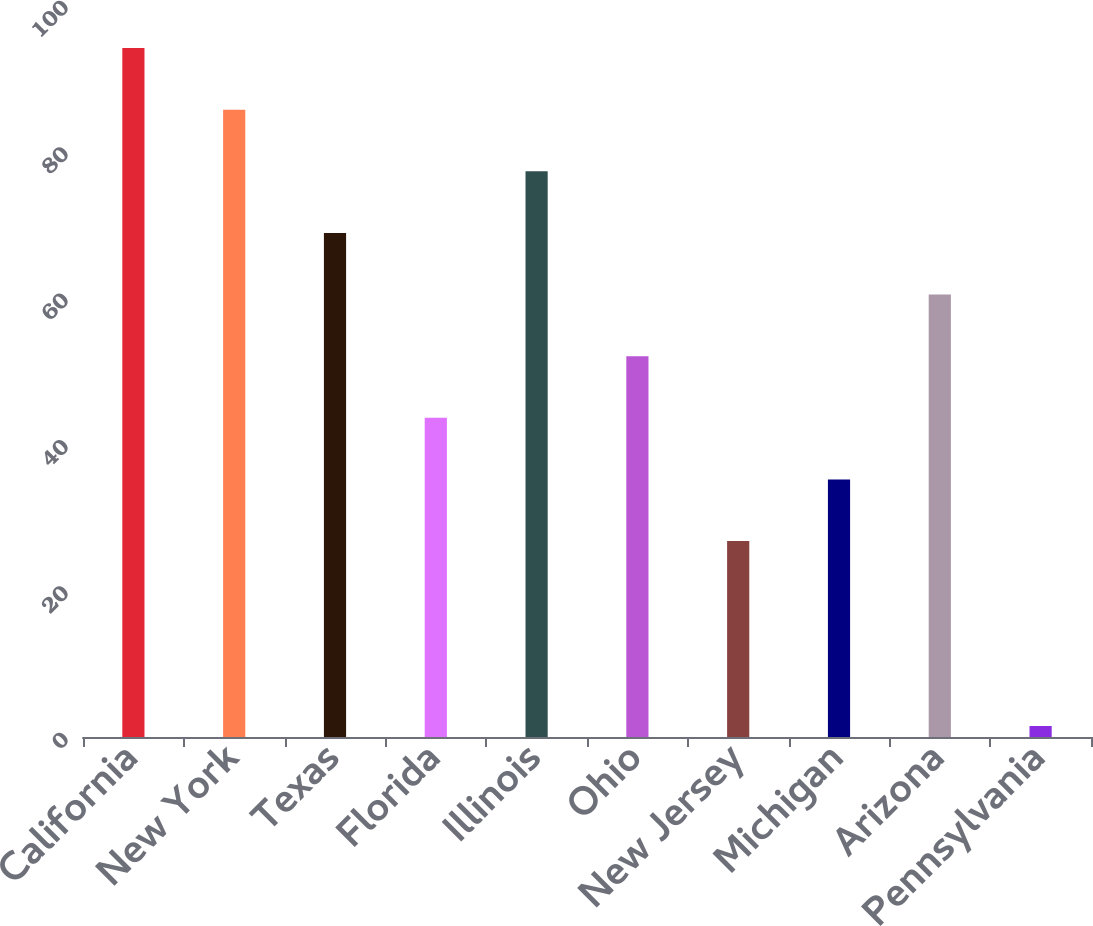<chart> <loc_0><loc_0><loc_500><loc_500><bar_chart><fcel>California<fcel>New York<fcel>Texas<fcel>Florida<fcel>Illinois<fcel>Ohio<fcel>New Jersey<fcel>Michigan<fcel>Arizona<fcel>Pennsylvania<nl><fcel>94.12<fcel>85.7<fcel>68.86<fcel>43.6<fcel>77.28<fcel>52.02<fcel>26.76<fcel>35.18<fcel>60.44<fcel>1.5<nl></chart> 